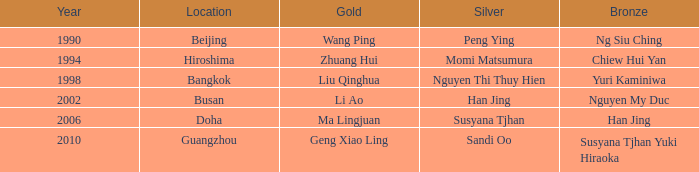Could you parse the entire table as a dict? {'header': ['Year', 'Location', 'Gold', 'Silver', 'Bronze'], 'rows': [['1990', 'Beijing', 'Wang Ping', 'Peng Ying', 'Ng Siu Ching'], ['1994', 'Hiroshima', 'Zhuang Hui', 'Momi Matsumura', 'Chiew Hui Yan'], ['1998', 'Bangkok', 'Liu Qinghua', 'Nguyen Thi Thuy Hien', 'Yuri Kaminiwa'], ['2002', 'Busan', 'Li Ao', 'Han Jing', 'Nguyen My Duc'], ['2006', 'Doha', 'Ma Lingjuan', 'Susyana Tjhan', 'Han Jing'], ['2010', 'Guangzhou', 'Geng Xiao Ling', 'Sandi Oo', 'Susyana Tjhan Yuki Hiraoka']]} What Silver has the Location of Guangzhou? Sandi Oo. 